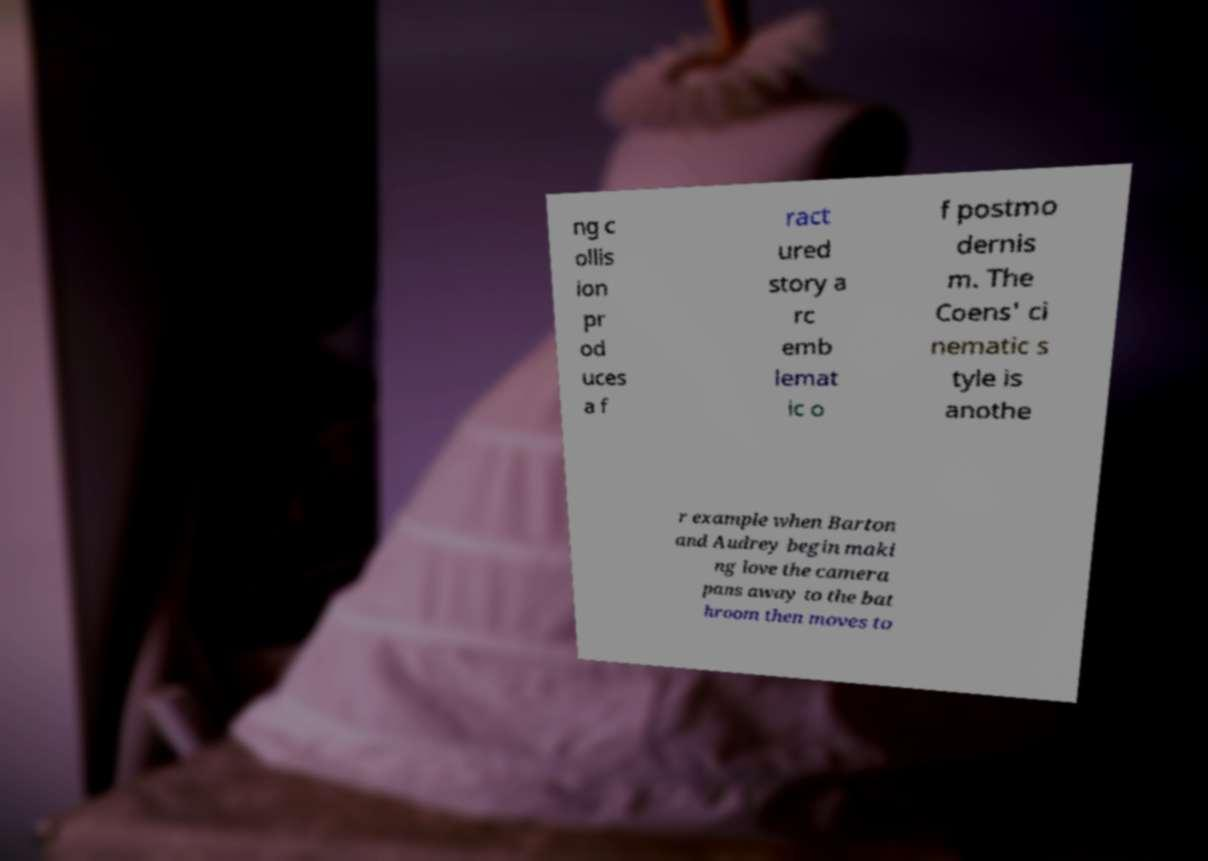Can you accurately transcribe the text from the provided image for me? ng c ollis ion pr od uces a f ract ured story a rc emb lemat ic o f postmo dernis m. The Coens' ci nematic s tyle is anothe r example when Barton and Audrey begin maki ng love the camera pans away to the bat hroom then moves to 